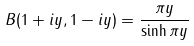<formula> <loc_0><loc_0><loc_500><loc_500>B ( 1 + i y , 1 - i y ) = { \frac { \pi y } { \sinh \pi y } }</formula> 